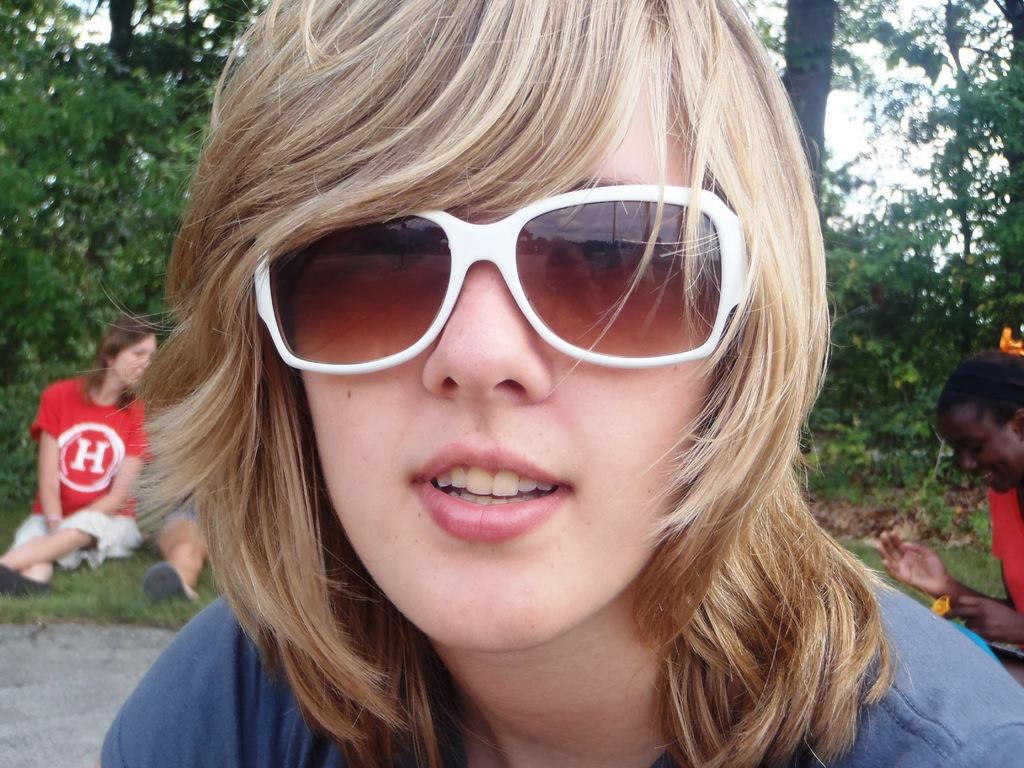Who is present in the image? There is a woman in the image. What is the woman wearing on her face? The woman is wearing goggles. What is the woman's facial expression? The woman is smiling. What can be seen in the background of the image? There are trees, people sitting on the grass, and the sky visible in the background of the image. Can you see any cobwebs in the image? There are no cobwebs present in the image. What type of cherries is the woman holding in the image? There are no cherries present in the image. 